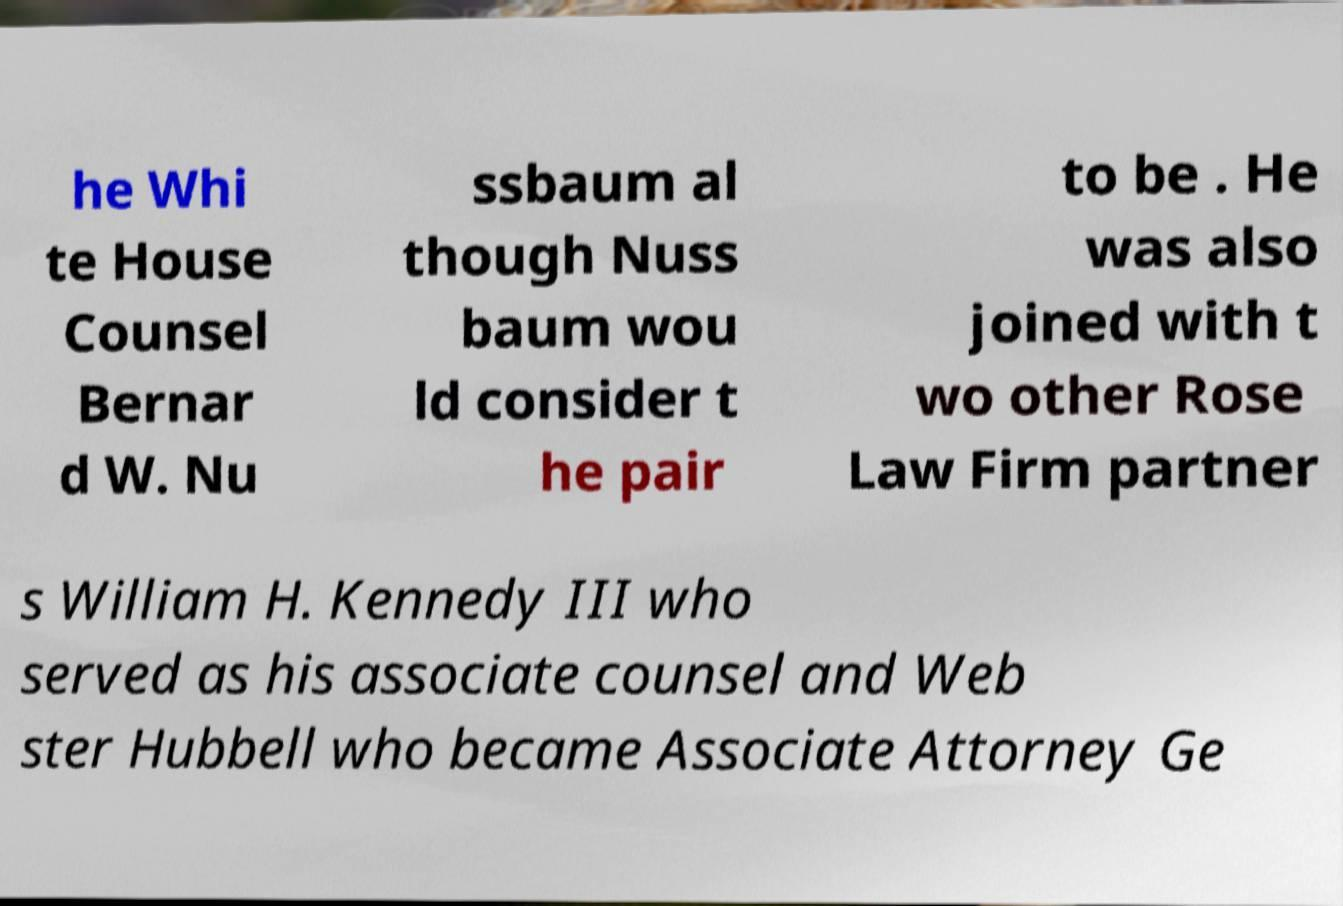Can you read and provide the text displayed in the image?This photo seems to have some interesting text. Can you extract and type it out for me? he Whi te House Counsel Bernar d W. Nu ssbaum al though Nuss baum wou ld consider t he pair to be . He was also joined with t wo other Rose Law Firm partner s William H. Kennedy III who served as his associate counsel and Web ster Hubbell who became Associate Attorney Ge 